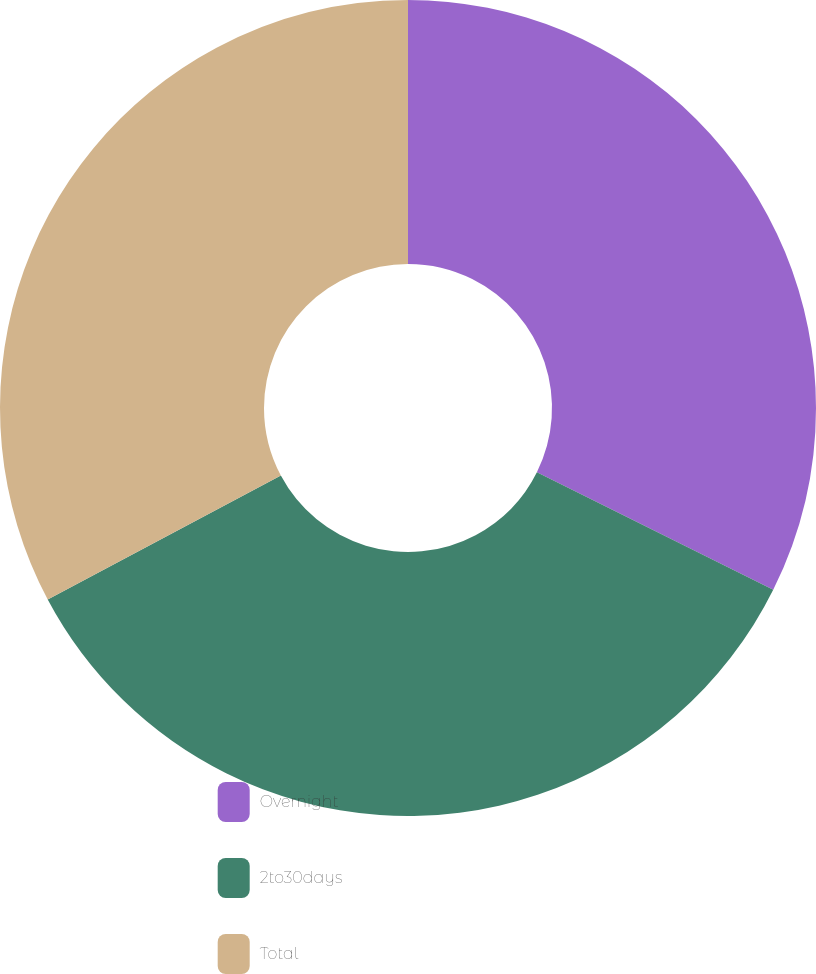<chart> <loc_0><loc_0><loc_500><loc_500><pie_chart><fcel>Overnight<fcel>2to30days<fcel>Total<nl><fcel>32.35%<fcel>34.87%<fcel>32.77%<nl></chart> 